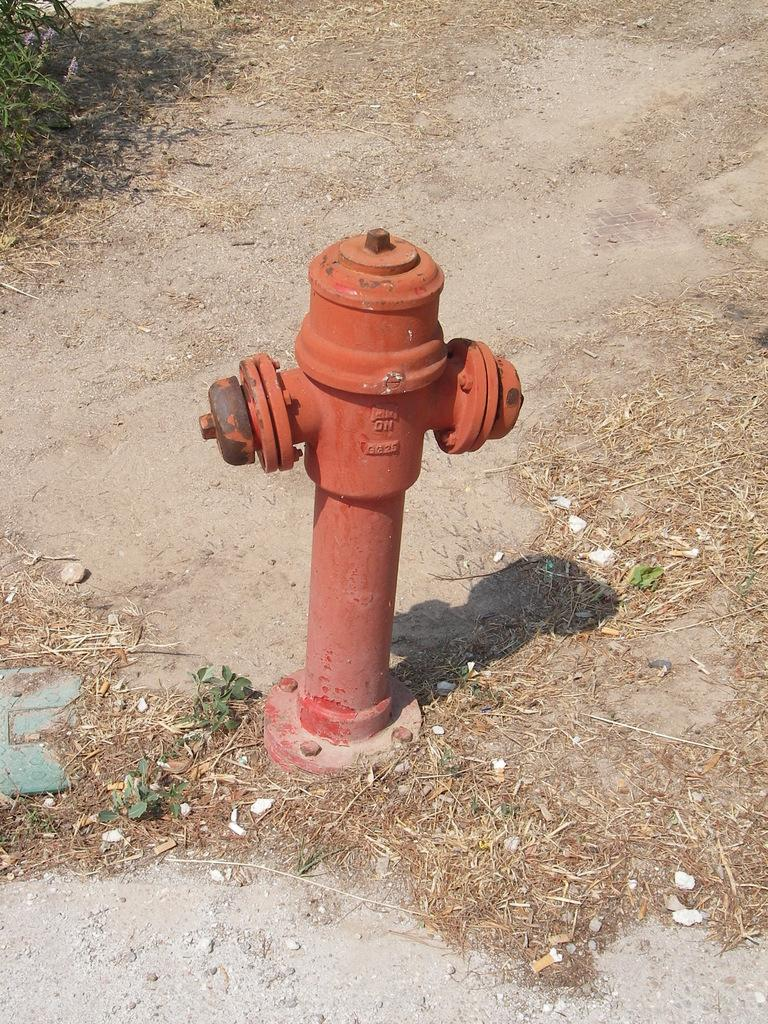What is the main object in the image? There is a fire hydrant in the image. What else can be seen on the left side of the image? There is an object on the left side of the image. What type of vegetation is present in the image? There are plants in the image. How many girls are sneezing in the image? There are no girls or sneezing in the image; it features a fire hydrant and plants. What does the grandfather say to the fire hydrant in the image? There is no grandfather or dialogue present in the image. 